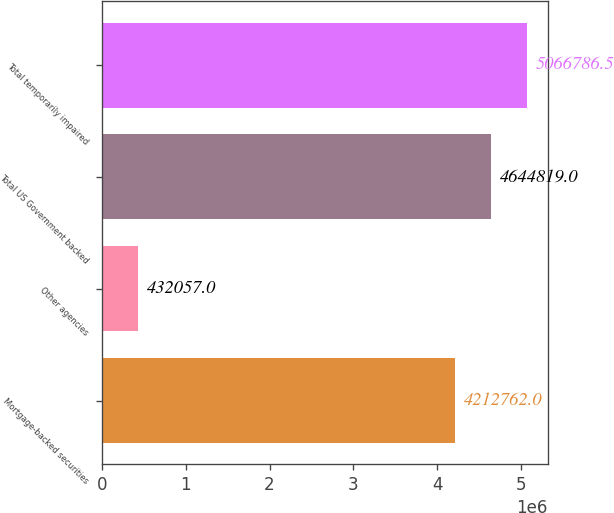Convert chart. <chart><loc_0><loc_0><loc_500><loc_500><bar_chart><fcel>Mortgage-backed securities<fcel>Other agencies<fcel>Total US Government backed<fcel>Total temporarily impaired<nl><fcel>4.21276e+06<fcel>432057<fcel>4.64482e+06<fcel>5.06679e+06<nl></chart> 